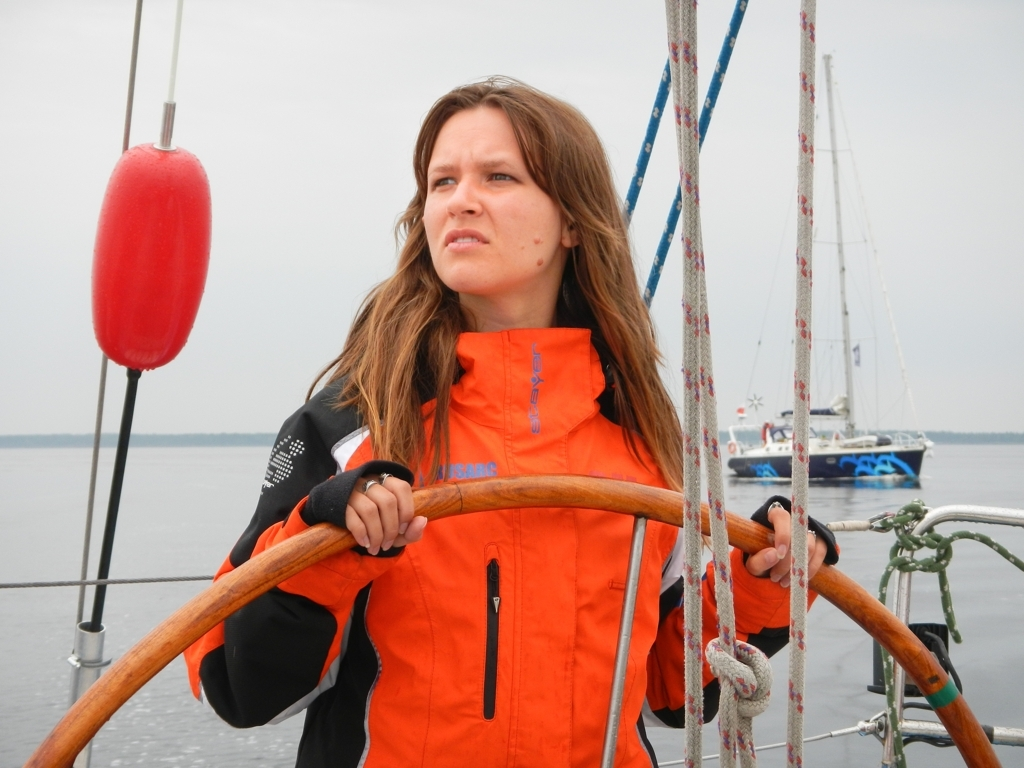What does the person's expression convey about their experience or situation? The individual's expression is one of focus and concentration. The slightly furrowed brows and gaze directed off-frame could indicate that she's attentively navigating or looking out for something while steering. This expression can often be associated with someone who is fully engaged in the task at hand, which in this context is likely related to sailing. 